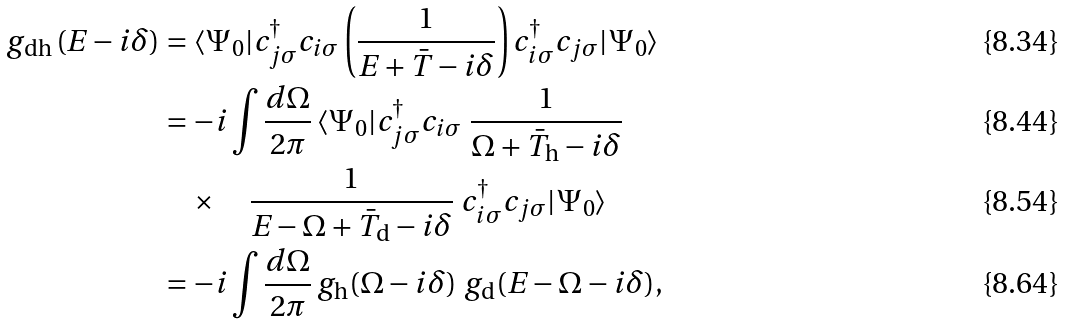Convert formula to latex. <formula><loc_0><loc_0><loc_500><loc_500>g _ { \text {dh} } \left ( E - i \delta \right ) & = \langle \Psi _ { 0 } | c ^ { \dagger } _ { j \sigma } c _ { i \sigma } \left ( \frac { 1 } { E + \bar { T } - i \delta } \right ) c ^ { \dagger } _ { i \sigma } c _ { j \sigma } | \Psi _ { 0 } \rangle \\ & = - i \int \frac { d \Omega } { 2 \pi } \, \langle \Psi _ { 0 } | c ^ { \dagger } _ { j \sigma } c _ { i \sigma } \ \frac { 1 } { \Omega + \bar { T } _ { \text {h} } - i \delta } \\ & \quad \times \quad \frac { 1 } { E - \Omega + \bar { T } _ { \text {d} } - i \delta } \ c ^ { \dagger } _ { i \sigma } c _ { j \sigma } | \Psi _ { 0 } \rangle \\ & = - i \int \frac { d \Omega } { 2 \pi } \, g _ { \text {h} } ( \Omega - i \delta ) \ g _ { \text {d} } ( E - \Omega - i \delta ) ,</formula> 